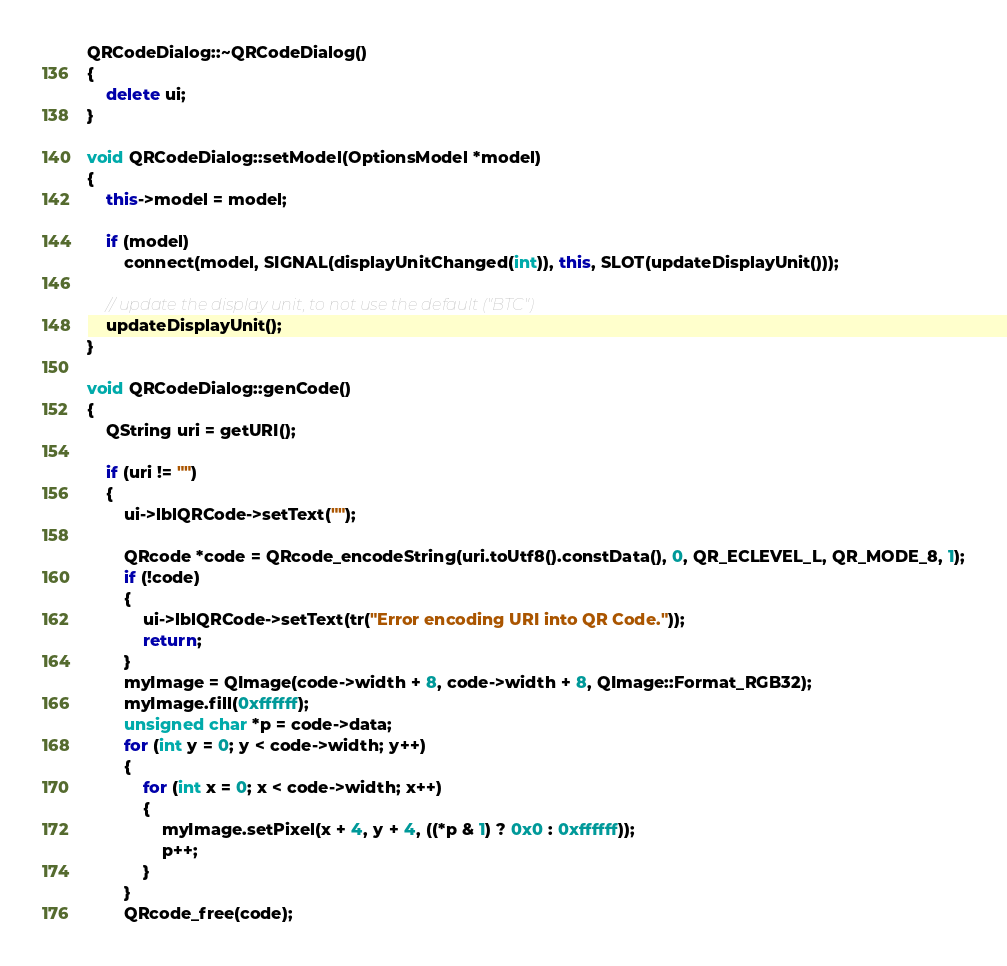Convert code to text. <code><loc_0><loc_0><loc_500><loc_500><_C++_>
QRCodeDialog::~QRCodeDialog()
{
    delete ui;
}

void QRCodeDialog::setModel(OptionsModel *model)
{
    this->model = model;

    if (model)
        connect(model, SIGNAL(displayUnitChanged(int)), this, SLOT(updateDisplayUnit()));

    // update the display unit, to not use the default ("BTC")
    updateDisplayUnit();
}

void QRCodeDialog::genCode()
{
    QString uri = getURI();

    if (uri != "")
    {
        ui->lblQRCode->setText("");

        QRcode *code = QRcode_encodeString(uri.toUtf8().constData(), 0, QR_ECLEVEL_L, QR_MODE_8, 1);
        if (!code)
        {
            ui->lblQRCode->setText(tr("Error encoding URI into QR Code."));
            return;
        }
        myImage = QImage(code->width + 8, code->width + 8, QImage::Format_RGB32);
        myImage.fill(0xffffff);
        unsigned char *p = code->data;
        for (int y = 0; y < code->width; y++)
        {
            for (int x = 0; x < code->width; x++)
            {
                myImage.setPixel(x + 4, y + 4, ((*p & 1) ? 0x0 : 0xffffff));
                p++;
            }
        }
        QRcode_free(code);
</code> 